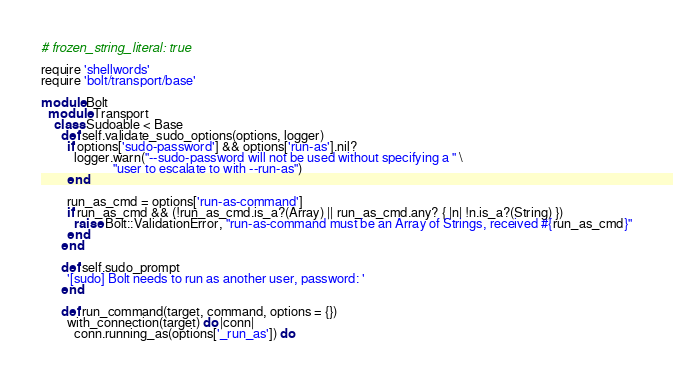<code> <loc_0><loc_0><loc_500><loc_500><_Ruby_># frozen_string_literal: true

require 'shellwords'
require 'bolt/transport/base'

module Bolt
  module Transport
    class Sudoable < Base
      def self.validate_sudo_options(options, logger)
        if options['sudo-password'] && options['run-as'].nil?
          logger.warn("--sudo-password will not be used without specifying a " \
                      "user to escalate to with --run-as")
        end

        run_as_cmd = options['run-as-command']
        if run_as_cmd && (!run_as_cmd.is_a?(Array) || run_as_cmd.any? { |n| !n.is_a?(String) })
          raise Bolt::ValidationError, "run-as-command must be an Array of Strings, received #{run_as_cmd}"
        end
      end

      def self.sudo_prompt
        '[sudo] Bolt needs to run as another user, password: '
      end

      def run_command(target, command, options = {})
        with_connection(target) do |conn|
          conn.running_as(options['_run_as']) do</code> 